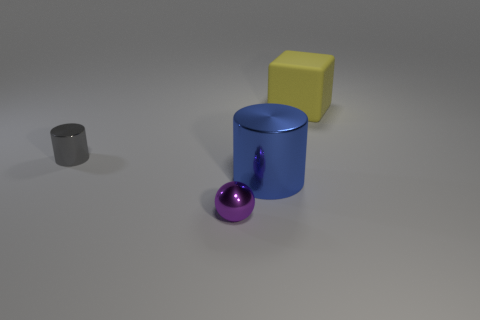Does the composition of the objects suggest anything about their purpose or context? The objects might be simple 3D models placed for illustrative or educational purposes, such as in a rendering or modeling software tutorial. Their basic shapes and arrangement don't suggest a natural setting, but rather an artificial or teaching environment. 